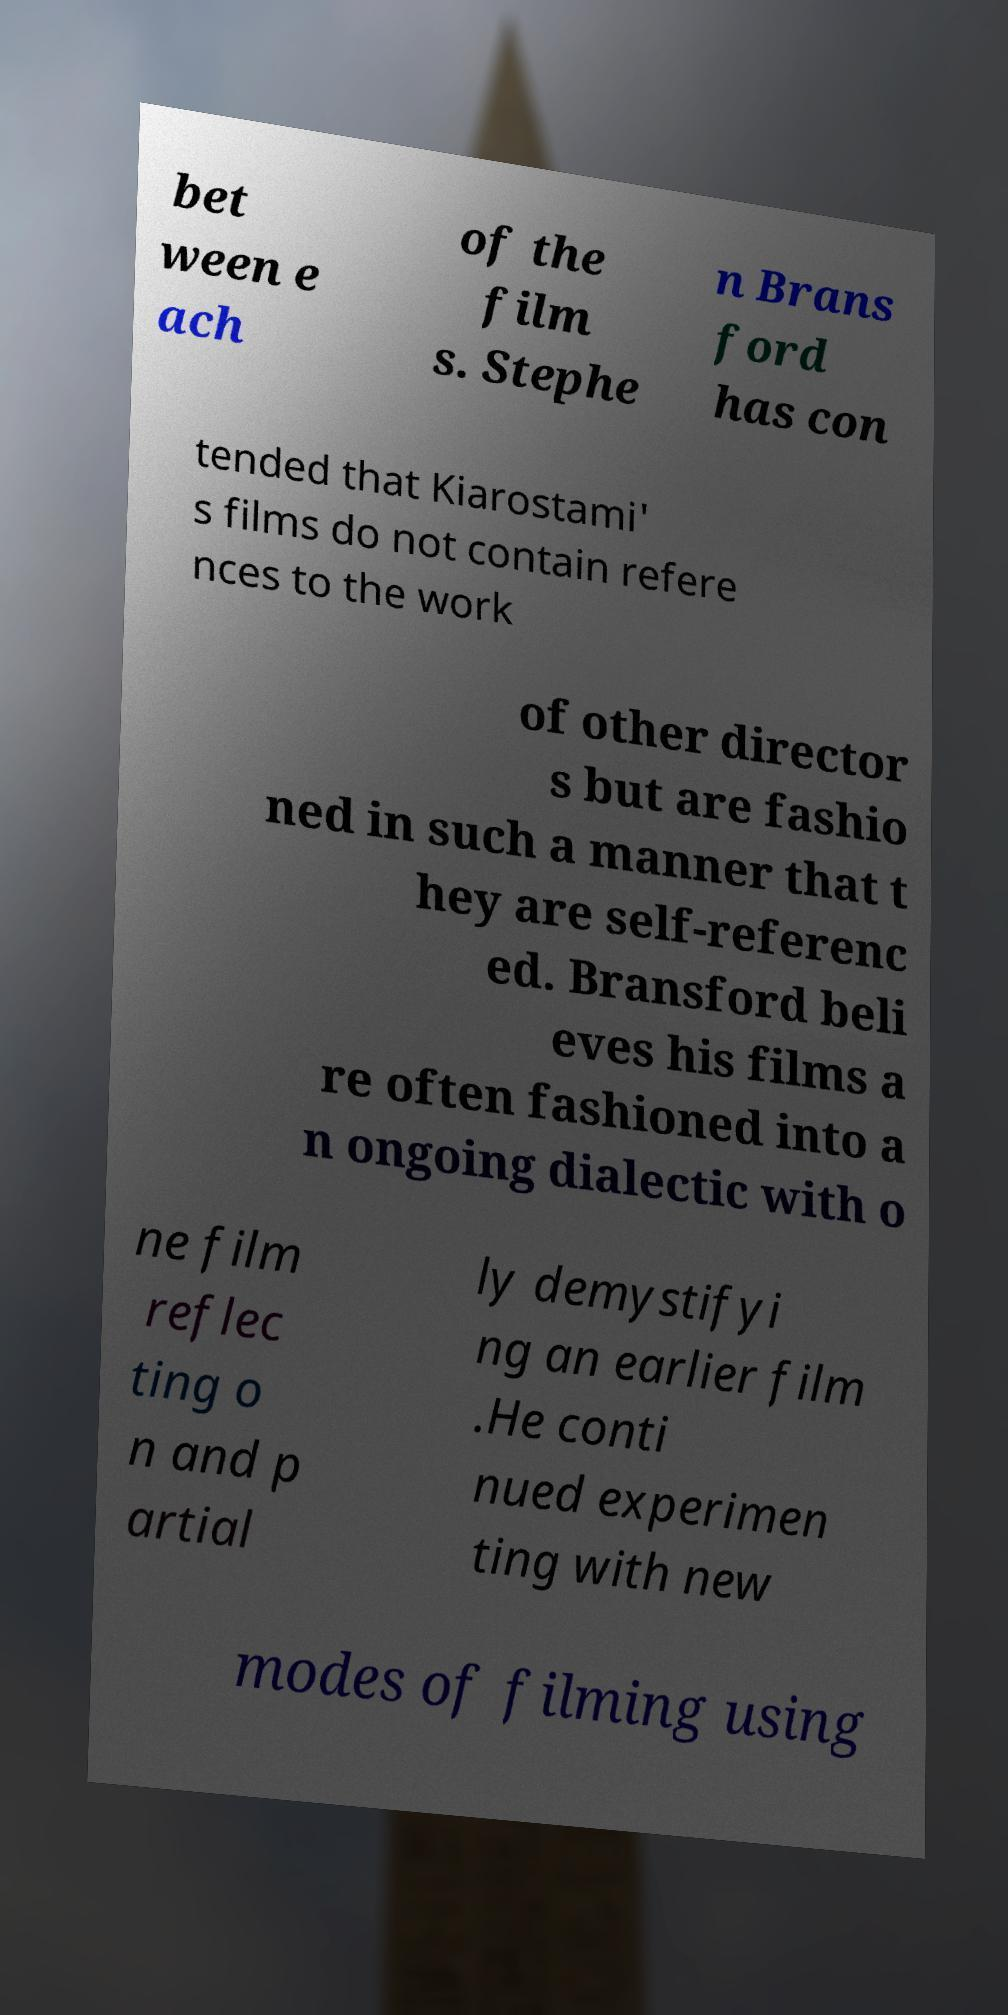I need the written content from this picture converted into text. Can you do that? bet ween e ach of the film s. Stephe n Brans ford has con tended that Kiarostami' s films do not contain refere nces to the work of other director s but are fashio ned in such a manner that t hey are self-referenc ed. Bransford beli eves his films a re often fashioned into a n ongoing dialectic with o ne film reflec ting o n and p artial ly demystifyi ng an earlier film .He conti nued experimen ting with new modes of filming using 